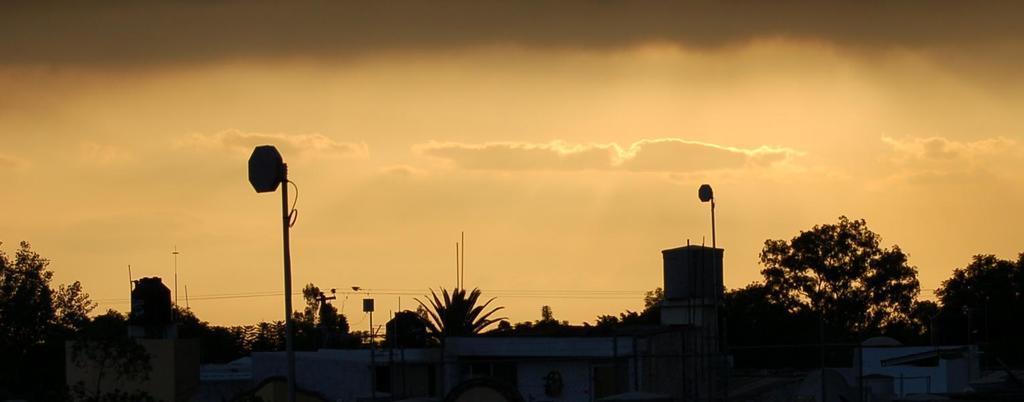Could you give a brief overview of what you see in this image? It looks like sunset in the evening, at the bottom there are houses and trees. At the top it is the sky. 